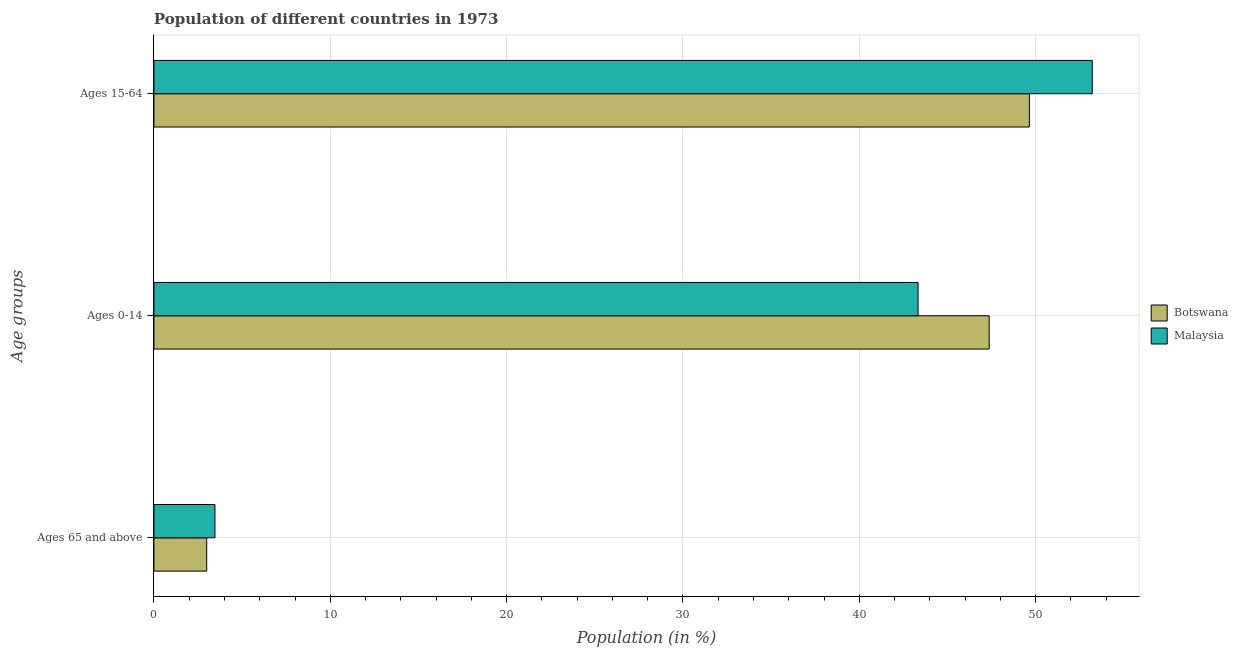How many different coloured bars are there?
Your answer should be compact. 2. How many groups of bars are there?
Offer a terse response. 3. Are the number of bars on each tick of the Y-axis equal?
Keep it short and to the point. Yes. What is the label of the 2nd group of bars from the top?
Ensure brevity in your answer.  Ages 0-14. What is the percentage of population within the age-group 0-14 in Malaysia?
Ensure brevity in your answer.  43.33. Across all countries, what is the maximum percentage of population within the age-group 0-14?
Your answer should be compact. 47.36. Across all countries, what is the minimum percentage of population within the age-group 15-64?
Your answer should be compact. 49.64. In which country was the percentage of population within the age-group of 65 and above maximum?
Offer a terse response. Malaysia. In which country was the percentage of population within the age-group 0-14 minimum?
Your response must be concise. Malaysia. What is the total percentage of population within the age-group of 65 and above in the graph?
Your answer should be compact. 6.45. What is the difference between the percentage of population within the age-group of 65 and above in Malaysia and that in Botswana?
Give a very brief answer. 0.47. What is the difference between the percentage of population within the age-group 0-14 in Botswana and the percentage of population within the age-group 15-64 in Malaysia?
Make the answer very short. -5.84. What is the average percentage of population within the age-group of 65 and above per country?
Your response must be concise. 3.23. What is the difference between the percentage of population within the age-group of 65 and above and percentage of population within the age-group 15-64 in Botswana?
Provide a succinct answer. -46.65. What is the ratio of the percentage of population within the age-group 0-14 in Botswana to that in Malaysia?
Offer a very short reply. 1.09. Is the difference between the percentage of population within the age-group 15-64 in Malaysia and Botswana greater than the difference between the percentage of population within the age-group 0-14 in Malaysia and Botswana?
Your answer should be very brief. Yes. What is the difference between the highest and the second highest percentage of population within the age-group 0-14?
Offer a very short reply. 4.03. What is the difference between the highest and the lowest percentage of population within the age-group 0-14?
Your answer should be compact. 4.03. In how many countries, is the percentage of population within the age-group 0-14 greater than the average percentage of population within the age-group 0-14 taken over all countries?
Make the answer very short. 1. What does the 1st bar from the top in Ages 65 and above represents?
Offer a very short reply. Malaysia. What does the 1st bar from the bottom in Ages 65 and above represents?
Give a very brief answer. Botswana. Is it the case that in every country, the sum of the percentage of population within the age-group of 65 and above and percentage of population within the age-group 0-14 is greater than the percentage of population within the age-group 15-64?
Offer a very short reply. No. How many bars are there?
Provide a short and direct response. 6. What is the difference between two consecutive major ticks on the X-axis?
Your response must be concise. 10. Are the values on the major ticks of X-axis written in scientific E-notation?
Provide a short and direct response. No. Does the graph contain any zero values?
Your response must be concise. No. Does the graph contain grids?
Provide a succinct answer. Yes. How are the legend labels stacked?
Provide a short and direct response. Vertical. What is the title of the graph?
Your response must be concise. Population of different countries in 1973. What is the label or title of the X-axis?
Offer a very short reply. Population (in %). What is the label or title of the Y-axis?
Make the answer very short. Age groups. What is the Population (in %) in Botswana in Ages 65 and above?
Provide a short and direct response. 2.99. What is the Population (in %) of Malaysia in Ages 65 and above?
Make the answer very short. 3.46. What is the Population (in %) of Botswana in Ages 0-14?
Offer a terse response. 47.36. What is the Population (in %) in Malaysia in Ages 0-14?
Ensure brevity in your answer.  43.33. What is the Population (in %) of Botswana in Ages 15-64?
Keep it short and to the point. 49.64. What is the Population (in %) in Malaysia in Ages 15-64?
Give a very brief answer. 53.21. Across all Age groups, what is the maximum Population (in %) of Botswana?
Your response must be concise. 49.64. Across all Age groups, what is the maximum Population (in %) in Malaysia?
Keep it short and to the point. 53.21. Across all Age groups, what is the minimum Population (in %) in Botswana?
Make the answer very short. 2.99. Across all Age groups, what is the minimum Population (in %) of Malaysia?
Your response must be concise. 3.46. What is the total Population (in %) of Botswana in the graph?
Your response must be concise. 100. What is the difference between the Population (in %) of Botswana in Ages 65 and above and that in Ages 0-14?
Keep it short and to the point. -44.37. What is the difference between the Population (in %) of Malaysia in Ages 65 and above and that in Ages 0-14?
Give a very brief answer. -39.87. What is the difference between the Population (in %) in Botswana in Ages 65 and above and that in Ages 15-64?
Offer a terse response. -46.65. What is the difference between the Population (in %) in Malaysia in Ages 65 and above and that in Ages 15-64?
Offer a terse response. -49.75. What is the difference between the Population (in %) in Botswana in Ages 0-14 and that in Ages 15-64?
Keep it short and to the point. -2.28. What is the difference between the Population (in %) in Malaysia in Ages 0-14 and that in Ages 15-64?
Your answer should be compact. -9.88. What is the difference between the Population (in %) in Botswana in Ages 65 and above and the Population (in %) in Malaysia in Ages 0-14?
Provide a succinct answer. -40.34. What is the difference between the Population (in %) of Botswana in Ages 65 and above and the Population (in %) of Malaysia in Ages 15-64?
Offer a terse response. -50.22. What is the difference between the Population (in %) of Botswana in Ages 0-14 and the Population (in %) of Malaysia in Ages 15-64?
Provide a short and direct response. -5.84. What is the average Population (in %) of Botswana per Age groups?
Provide a succinct answer. 33.33. What is the average Population (in %) of Malaysia per Age groups?
Your answer should be compact. 33.33. What is the difference between the Population (in %) of Botswana and Population (in %) of Malaysia in Ages 65 and above?
Provide a short and direct response. -0.47. What is the difference between the Population (in %) in Botswana and Population (in %) in Malaysia in Ages 0-14?
Your answer should be compact. 4.03. What is the difference between the Population (in %) of Botswana and Population (in %) of Malaysia in Ages 15-64?
Ensure brevity in your answer.  -3.57. What is the ratio of the Population (in %) of Botswana in Ages 65 and above to that in Ages 0-14?
Offer a terse response. 0.06. What is the ratio of the Population (in %) in Malaysia in Ages 65 and above to that in Ages 0-14?
Make the answer very short. 0.08. What is the ratio of the Population (in %) in Botswana in Ages 65 and above to that in Ages 15-64?
Ensure brevity in your answer.  0.06. What is the ratio of the Population (in %) of Malaysia in Ages 65 and above to that in Ages 15-64?
Your answer should be compact. 0.07. What is the ratio of the Population (in %) of Botswana in Ages 0-14 to that in Ages 15-64?
Give a very brief answer. 0.95. What is the ratio of the Population (in %) in Malaysia in Ages 0-14 to that in Ages 15-64?
Offer a terse response. 0.81. What is the difference between the highest and the second highest Population (in %) in Botswana?
Your answer should be compact. 2.28. What is the difference between the highest and the second highest Population (in %) in Malaysia?
Keep it short and to the point. 9.88. What is the difference between the highest and the lowest Population (in %) of Botswana?
Make the answer very short. 46.65. What is the difference between the highest and the lowest Population (in %) of Malaysia?
Your answer should be very brief. 49.75. 